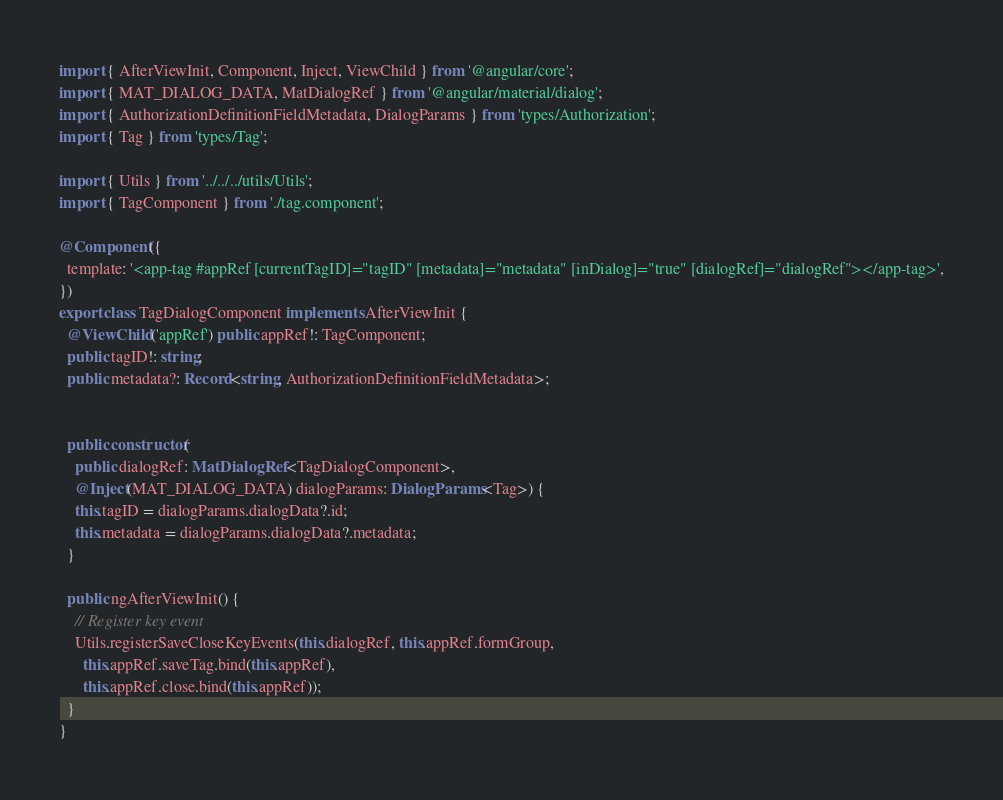Convert code to text. <code><loc_0><loc_0><loc_500><loc_500><_TypeScript_>import { AfterViewInit, Component, Inject, ViewChild } from '@angular/core';
import { MAT_DIALOG_DATA, MatDialogRef } from '@angular/material/dialog';
import { AuthorizationDefinitionFieldMetadata, DialogParams } from 'types/Authorization';
import { Tag } from 'types/Tag';

import { Utils } from '../../../utils/Utils';
import { TagComponent } from './tag.component';

@Component({
  template: '<app-tag #appRef [currentTagID]="tagID" [metadata]="metadata" [inDialog]="true" [dialogRef]="dialogRef"></app-tag>',
})
export class TagDialogComponent implements AfterViewInit {
  @ViewChild('appRef') public appRef!: TagComponent;
  public tagID!: string;
  public metadata?: Record<string, AuthorizationDefinitionFieldMetadata>;


  public constructor(
    public dialogRef: MatDialogRef<TagDialogComponent>,
    @Inject(MAT_DIALOG_DATA) dialogParams: DialogParams<Tag>) {
    this.tagID = dialogParams.dialogData?.id;
    this.metadata = dialogParams.dialogData?.metadata;
  }

  public ngAfterViewInit() {
    // Register key event
    Utils.registerSaveCloseKeyEvents(this.dialogRef, this.appRef.formGroup,
      this.appRef.saveTag.bind(this.appRef),
      this.appRef.close.bind(this.appRef));
  }
}
</code> 